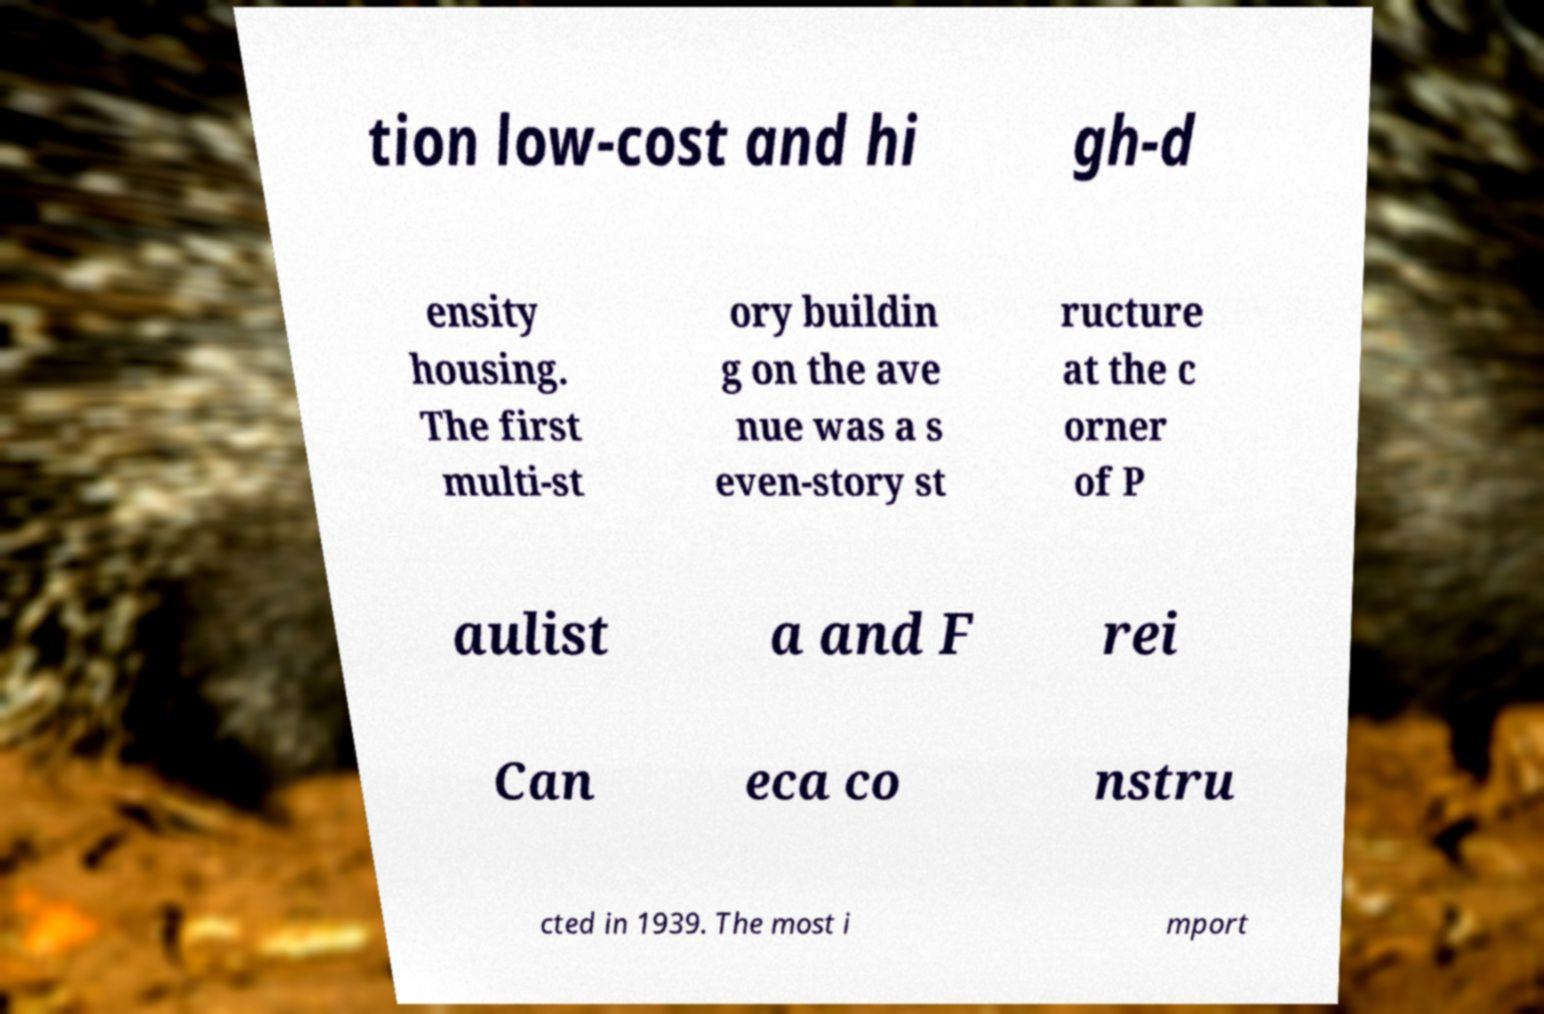Could you extract and type out the text from this image? tion low-cost and hi gh-d ensity housing. The first multi-st ory buildin g on the ave nue was a s even-story st ructure at the c orner of P aulist a and F rei Can eca co nstru cted in 1939. The most i mport 